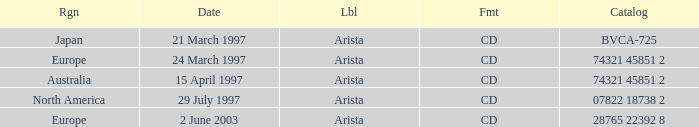What Date has the Region Europe and a Catalog of 74321 45851 2? 24 March 1997. 